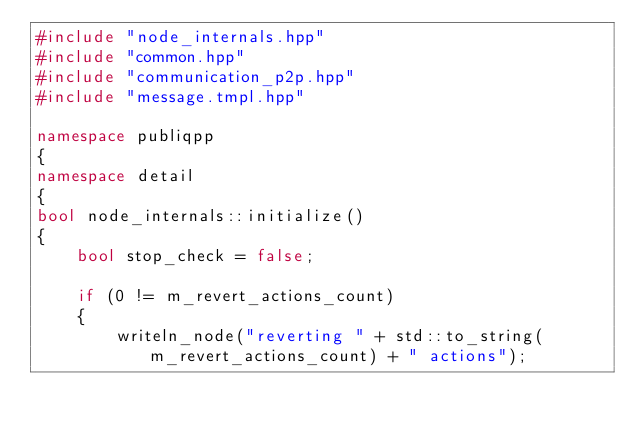Convert code to text. <code><loc_0><loc_0><loc_500><loc_500><_C++_>#include "node_internals.hpp"
#include "common.hpp"
#include "communication_p2p.hpp"
#include "message.tmpl.hpp"

namespace publiqpp
{
namespace detail
{
bool node_internals::initialize()
{
    bool stop_check = false;

    if (0 != m_revert_actions_count)
    {
        writeln_node("reverting " + std::to_string(m_revert_actions_count) + " actions");
</code> 